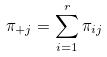<formula> <loc_0><loc_0><loc_500><loc_500>\pi _ { + j } = \sum _ { i = 1 } ^ { r } \pi _ { i j }</formula> 